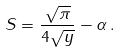<formula> <loc_0><loc_0><loc_500><loc_500>S = \frac { \sqrt { \pi } } { 4 \sqrt { y } } - \alpha \, .</formula> 